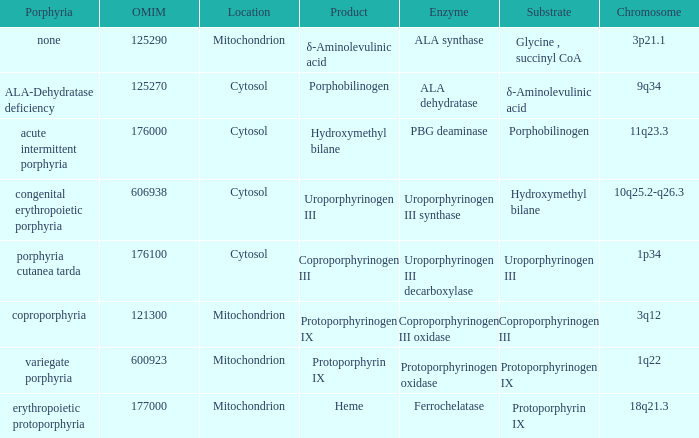What is protoporphyrin ix's substrate? Protoporphyrinogen IX. Can you parse all the data within this table? {'header': ['Porphyria', 'OMIM', 'Location', 'Product', 'Enzyme', 'Substrate', 'Chromosome'], 'rows': [['none', '125290', 'Mitochondrion', 'δ-Aminolevulinic acid', 'ALA synthase', 'Glycine , succinyl CoA', '3p21.1'], ['ALA-Dehydratase deficiency', '125270', 'Cytosol', 'Porphobilinogen', 'ALA dehydratase', 'δ-Aminolevulinic acid', '9q34'], ['acute intermittent porphyria', '176000', 'Cytosol', 'Hydroxymethyl bilane', 'PBG deaminase', 'Porphobilinogen', '11q23.3'], ['congenital erythropoietic porphyria', '606938', 'Cytosol', 'Uroporphyrinogen III', 'Uroporphyrinogen III synthase', 'Hydroxymethyl bilane', '10q25.2-q26.3'], ['porphyria cutanea tarda', '176100', 'Cytosol', 'Coproporphyrinogen III', 'Uroporphyrinogen III decarboxylase', 'Uroporphyrinogen III', '1p34'], ['coproporphyria', '121300', 'Mitochondrion', 'Protoporphyrinogen IX', 'Coproporphyrinogen III oxidase', 'Coproporphyrinogen III', '3q12'], ['variegate porphyria', '600923', 'Mitochondrion', 'Protoporphyrin IX', 'Protoporphyrinogen oxidase', 'Protoporphyrinogen IX', '1q22'], ['erythropoietic protoporphyria', '177000', 'Mitochondrion', 'Heme', 'Ferrochelatase', 'Protoporphyrin IX', '18q21.3']]} 